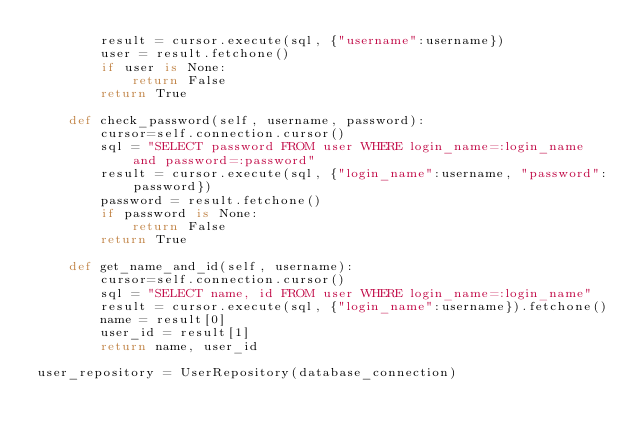Convert code to text. <code><loc_0><loc_0><loc_500><loc_500><_Python_>        result = cursor.execute(sql, {"username":username})
        user = result.fetchone()
        if user is None:
            return False
        return True

    def check_password(self, username, password):
        cursor=self.connection.cursor()
        sql = "SELECT password FROM user WHERE login_name=:login_name and password=:password"
        result = cursor.execute(sql, {"login_name":username, "password":password})
        password = result.fetchone()
        if password is None:
            return False
        return True

    def get_name_and_id(self, username):
        cursor=self.connection.cursor()
        sql = "SELECT name, id FROM user WHERE login_name=:login_name"
        result = cursor.execute(sql, {"login_name":username}).fetchone()
        name = result[0]
        user_id = result[1]
        return name, user_id

user_repository = UserRepository(database_connection)
</code> 